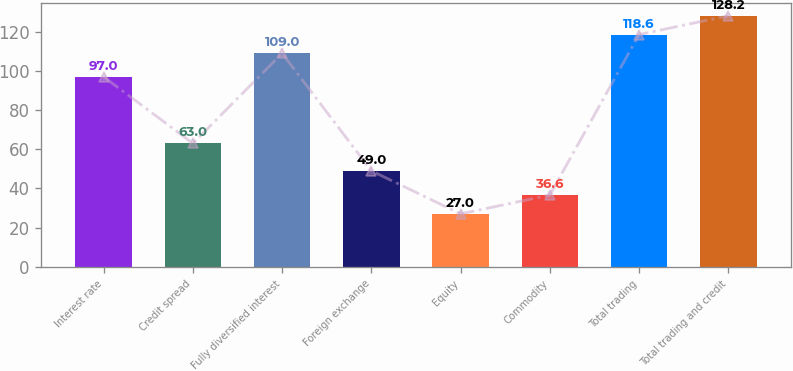Convert chart to OTSL. <chart><loc_0><loc_0><loc_500><loc_500><bar_chart><fcel>Interest rate<fcel>Credit spread<fcel>Fully diversified interest<fcel>Foreign exchange<fcel>Equity<fcel>Commodity<fcel>Total trading<fcel>Total trading and credit<nl><fcel>97<fcel>63<fcel>109<fcel>49<fcel>27<fcel>36.6<fcel>118.6<fcel>128.2<nl></chart> 